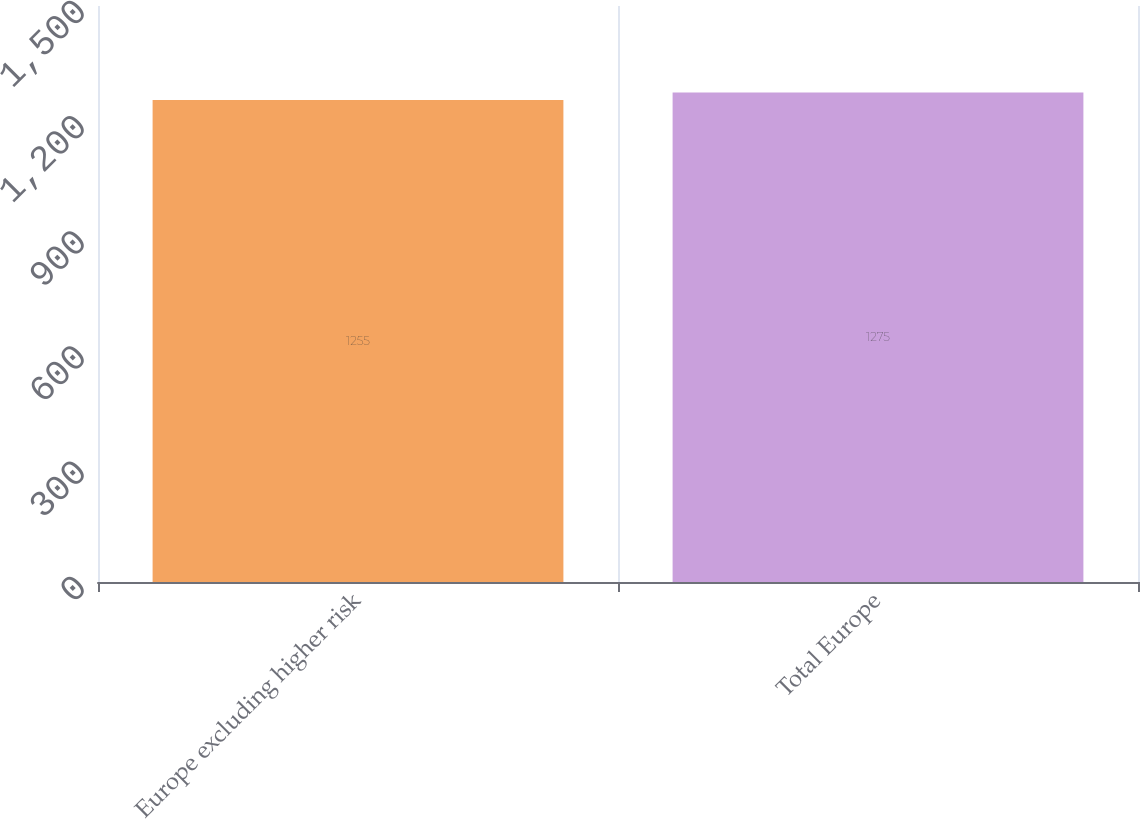Convert chart. <chart><loc_0><loc_0><loc_500><loc_500><bar_chart><fcel>Europe excluding higher risk<fcel>Total Europe<nl><fcel>1255<fcel>1275<nl></chart> 